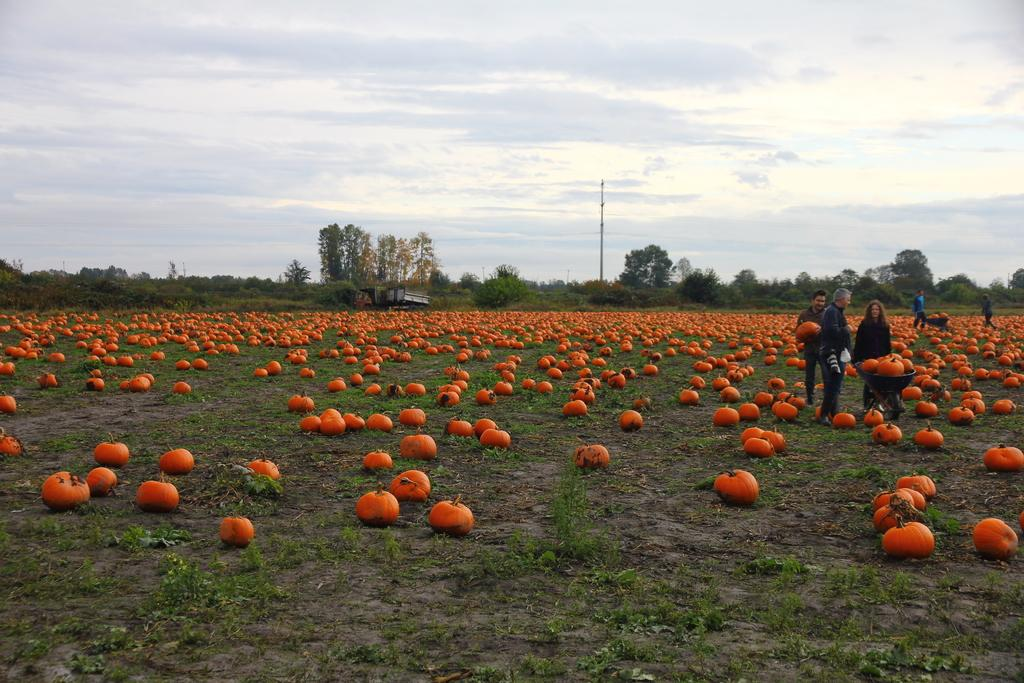What objects are present in the image? There are pumpkins, people, and a pole in the image. Can you describe the people in the image? There are no specific details about the people in the image, but they are present. What can be seen in the background of the image? There are trees in the background of the image. What is visible at the top of the image? The sky is visible at the top of the image, and clouds are present in the sky. What is the rate of the railway in the image? There is no railway present in the image, so it is not possible to determine the rate. 